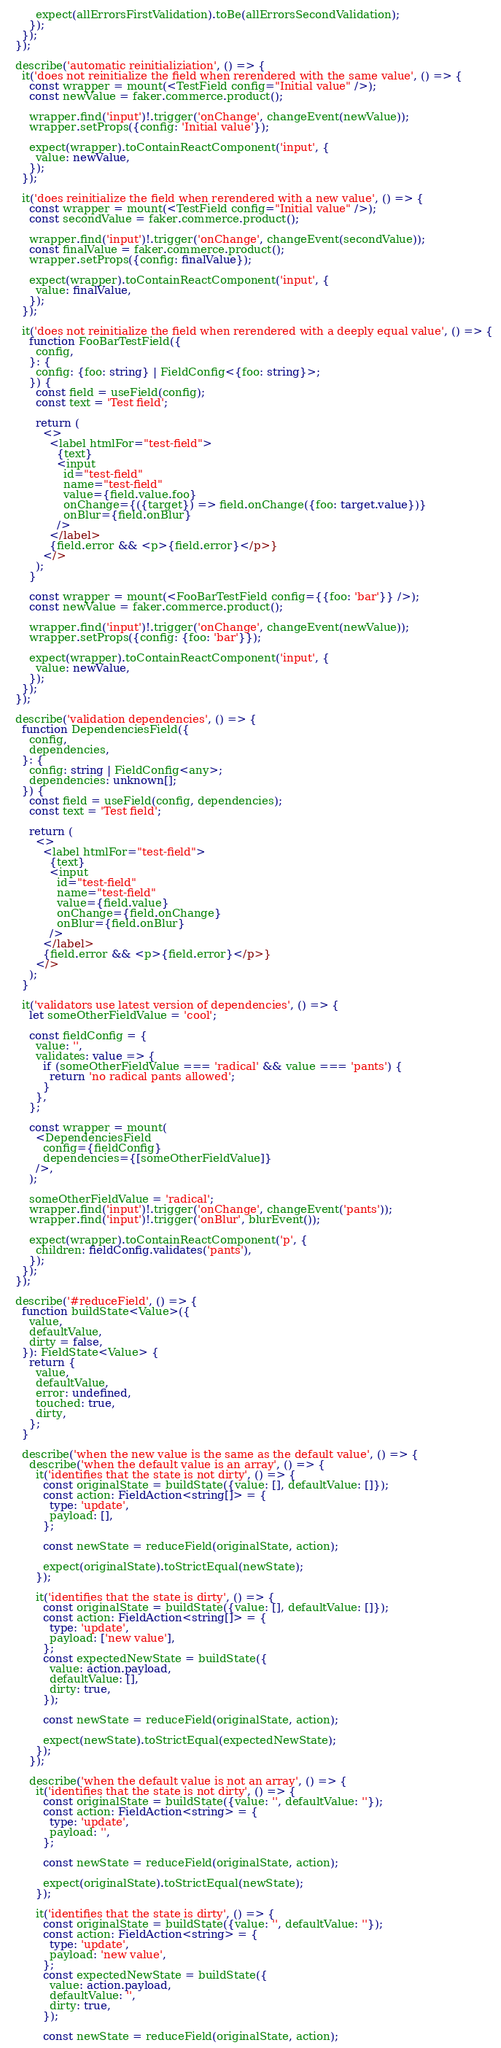<code> <loc_0><loc_0><loc_500><loc_500><_TypeScript_>
        expect(allErrorsFirstValidation).toBe(allErrorsSecondValidation);
      });
    });
  });

  describe('automatic reinitializiation', () => {
    it('does not reinitialize the field when rerendered with the same value', () => {
      const wrapper = mount(<TestField config="Initial value" />);
      const newValue = faker.commerce.product();

      wrapper.find('input')!.trigger('onChange', changeEvent(newValue));
      wrapper.setProps({config: 'Initial value'});

      expect(wrapper).toContainReactComponent('input', {
        value: newValue,
      });
    });

    it('does reinitialize the field when rerendered with a new value', () => {
      const wrapper = mount(<TestField config="Initial value" />);
      const secondValue = faker.commerce.product();

      wrapper.find('input')!.trigger('onChange', changeEvent(secondValue));
      const finalValue = faker.commerce.product();
      wrapper.setProps({config: finalValue});

      expect(wrapper).toContainReactComponent('input', {
        value: finalValue,
      });
    });

    it('does not reinitialize the field when rerendered with a deeply equal value', () => {
      function FooBarTestField({
        config,
      }: {
        config: {foo: string} | FieldConfig<{foo: string}>;
      }) {
        const field = useField(config);
        const text = 'Test field';

        return (
          <>
            <label htmlFor="test-field">
              {text}
              <input
                id="test-field"
                name="test-field"
                value={field.value.foo}
                onChange={({target}) => field.onChange({foo: target.value})}
                onBlur={field.onBlur}
              />
            </label>
            {field.error && <p>{field.error}</p>}
          </>
        );
      }

      const wrapper = mount(<FooBarTestField config={{foo: 'bar'}} />);
      const newValue = faker.commerce.product();

      wrapper.find('input')!.trigger('onChange', changeEvent(newValue));
      wrapper.setProps({config: {foo: 'bar'}});

      expect(wrapper).toContainReactComponent('input', {
        value: newValue,
      });
    });
  });

  describe('validation dependencies', () => {
    function DependenciesField({
      config,
      dependencies,
    }: {
      config: string | FieldConfig<any>;
      dependencies: unknown[];
    }) {
      const field = useField(config, dependencies);
      const text = 'Test field';

      return (
        <>
          <label htmlFor="test-field">
            {text}
            <input
              id="test-field"
              name="test-field"
              value={field.value}
              onChange={field.onChange}
              onBlur={field.onBlur}
            />
          </label>
          {field.error && <p>{field.error}</p>}
        </>
      );
    }

    it('validators use latest version of dependencies', () => {
      let someOtherFieldValue = 'cool';

      const fieldConfig = {
        value: '',
        validates: value => {
          if (someOtherFieldValue === 'radical' && value === 'pants') {
            return 'no radical pants allowed';
          }
        },
      };

      const wrapper = mount(
        <DependenciesField
          config={fieldConfig}
          dependencies={[someOtherFieldValue]}
        />,
      );

      someOtherFieldValue = 'radical';
      wrapper.find('input')!.trigger('onChange', changeEvent('pants'));
      wrapper.find('input')!.trigger('onBlur', blurEvent());

      expect(wrapper).toContainReactComponent('p', {
        children: fieldConfig.validates('pants'),
      });
    });
  });

  describe('#reduceField', () => {
    function buildState<Value>({
      value,
      defaultValue,
      dirty = false,
    }): FieldState<Value> {
      return {
        value,
        defaultValue,
        error: undefined,
        touched: true,
        dirty,
      };
    }

    describe('when the new value is the same as the default value', () => {
      describe('when the default value is an array', () => {
        it('identifies that the state is not dirty', () => {
          const originalState = buildState({value: [], defaultValue: []});
          const action: FieldAction<string[]> = {
            type: 'update',
            payload: [],
          };

          const newState = reduceField(originalState, action);

          expect(originalState).toStrictEqual(newState);
        });

        it('identifies that the state is dirty', () => {
          const originalState = buildState({value: [], defaultValue: []});
          const action: FieldAction<string[]> = {
            type: 'update',
            payload: ['new value'],
          };
          const expectedNewState = buildState({
            value: action.payload,
            defaultValue: [],
            dirty: true,
          });

          const newState = reduceField(originalState, action);

          expect(newState).toStrictEqual(expectedNewState);
        });
      });

      describe('when the default value is not an array', () => {
        it('identifies that the state is not dirty', () => {
          const originalState = buildState({value: '', defaultValue: ''});
          const action: FieldAction<string> = {
            type: 'update',
            payload: '',
          };

          const newState = reduceField(originalState, action);

          expect(originalState).toStrictEqual(newState);
        });

        it('identifies that the state is dirty', () => {
          const originalState = buildState({value: '', defaultValue: ''});
          const action: FieldAction<string> = {
            type: 'update',
            payload: 'new value',
          };
          const expectedNewState = buildState({
            value: action.payload,
            defaultValue: '',
            dirty: true,
          });

          const newState = reduceField(originalState, action);
</code> 